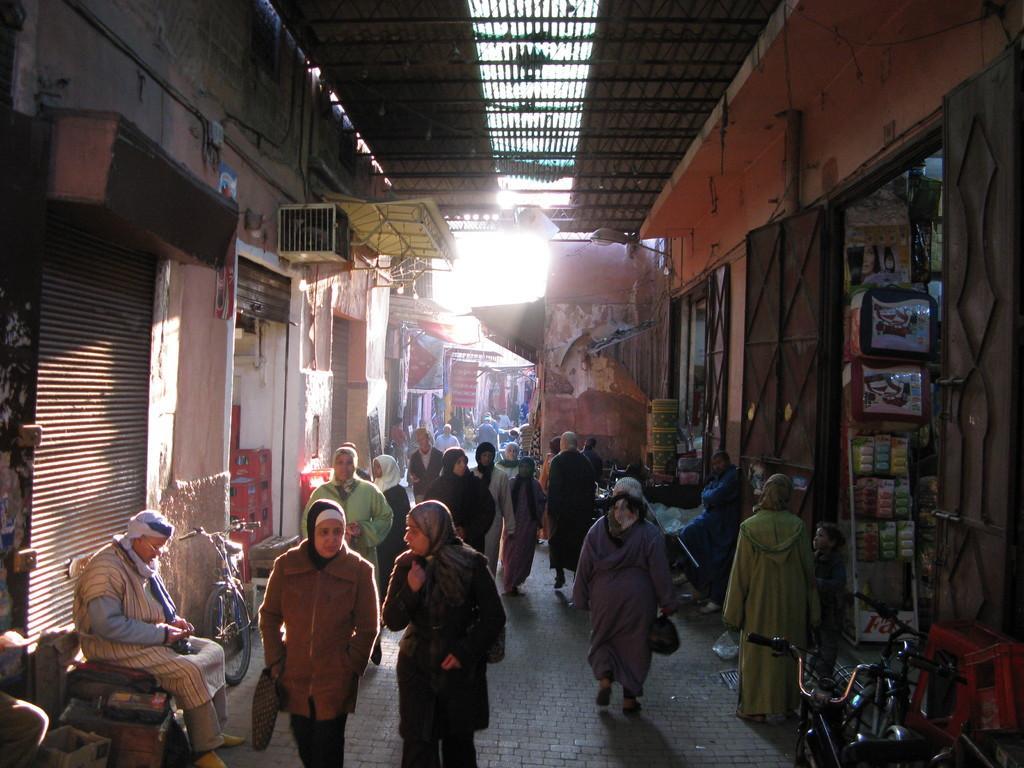How would you summarize this image in a sentence or two? There is a way where few persons are walking and there are few shops on either sides of it. 